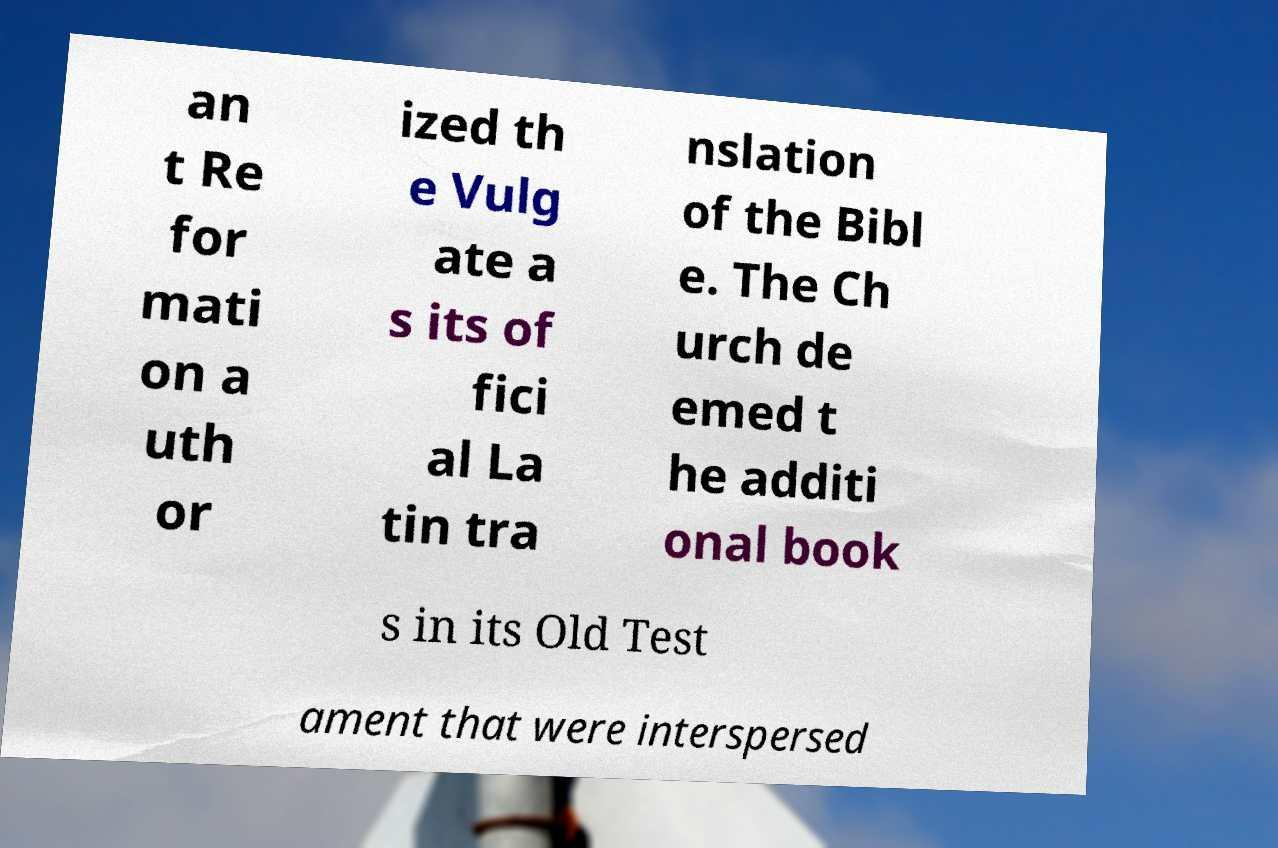Please identify and transcribe the text found in this image. an t Re for mati on a uth or ized th e Vulg ate a s its of fici al La tin tra nslation of the Bibl e. The Ch urch de emed t he additi onal book s in its Old Test ament that were interspersed 